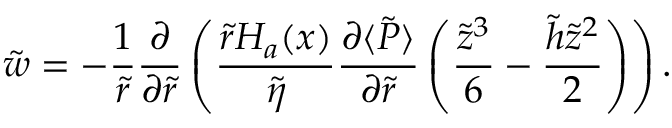<formula> <loc_0><loc_0><loc_500><loc_500>\tilde { w } = - \frac { 1 } { \tilde { r } } \frac { \partial } { \partial \tilde { r } } \left ( \frac { \tilde { r } H _ { a } ( x ) } { \tilde { \eta } } \frac { \partial \langle \tilde { P } \rangle } { \partial \tilde { r } } \left ( \frac { \tilde { z } ^ { 3 } } { 6 } - \frac { \tilde { h } \tilde { z } ^ { 2 } } { 2 } \right ) \right ) .</formula> 